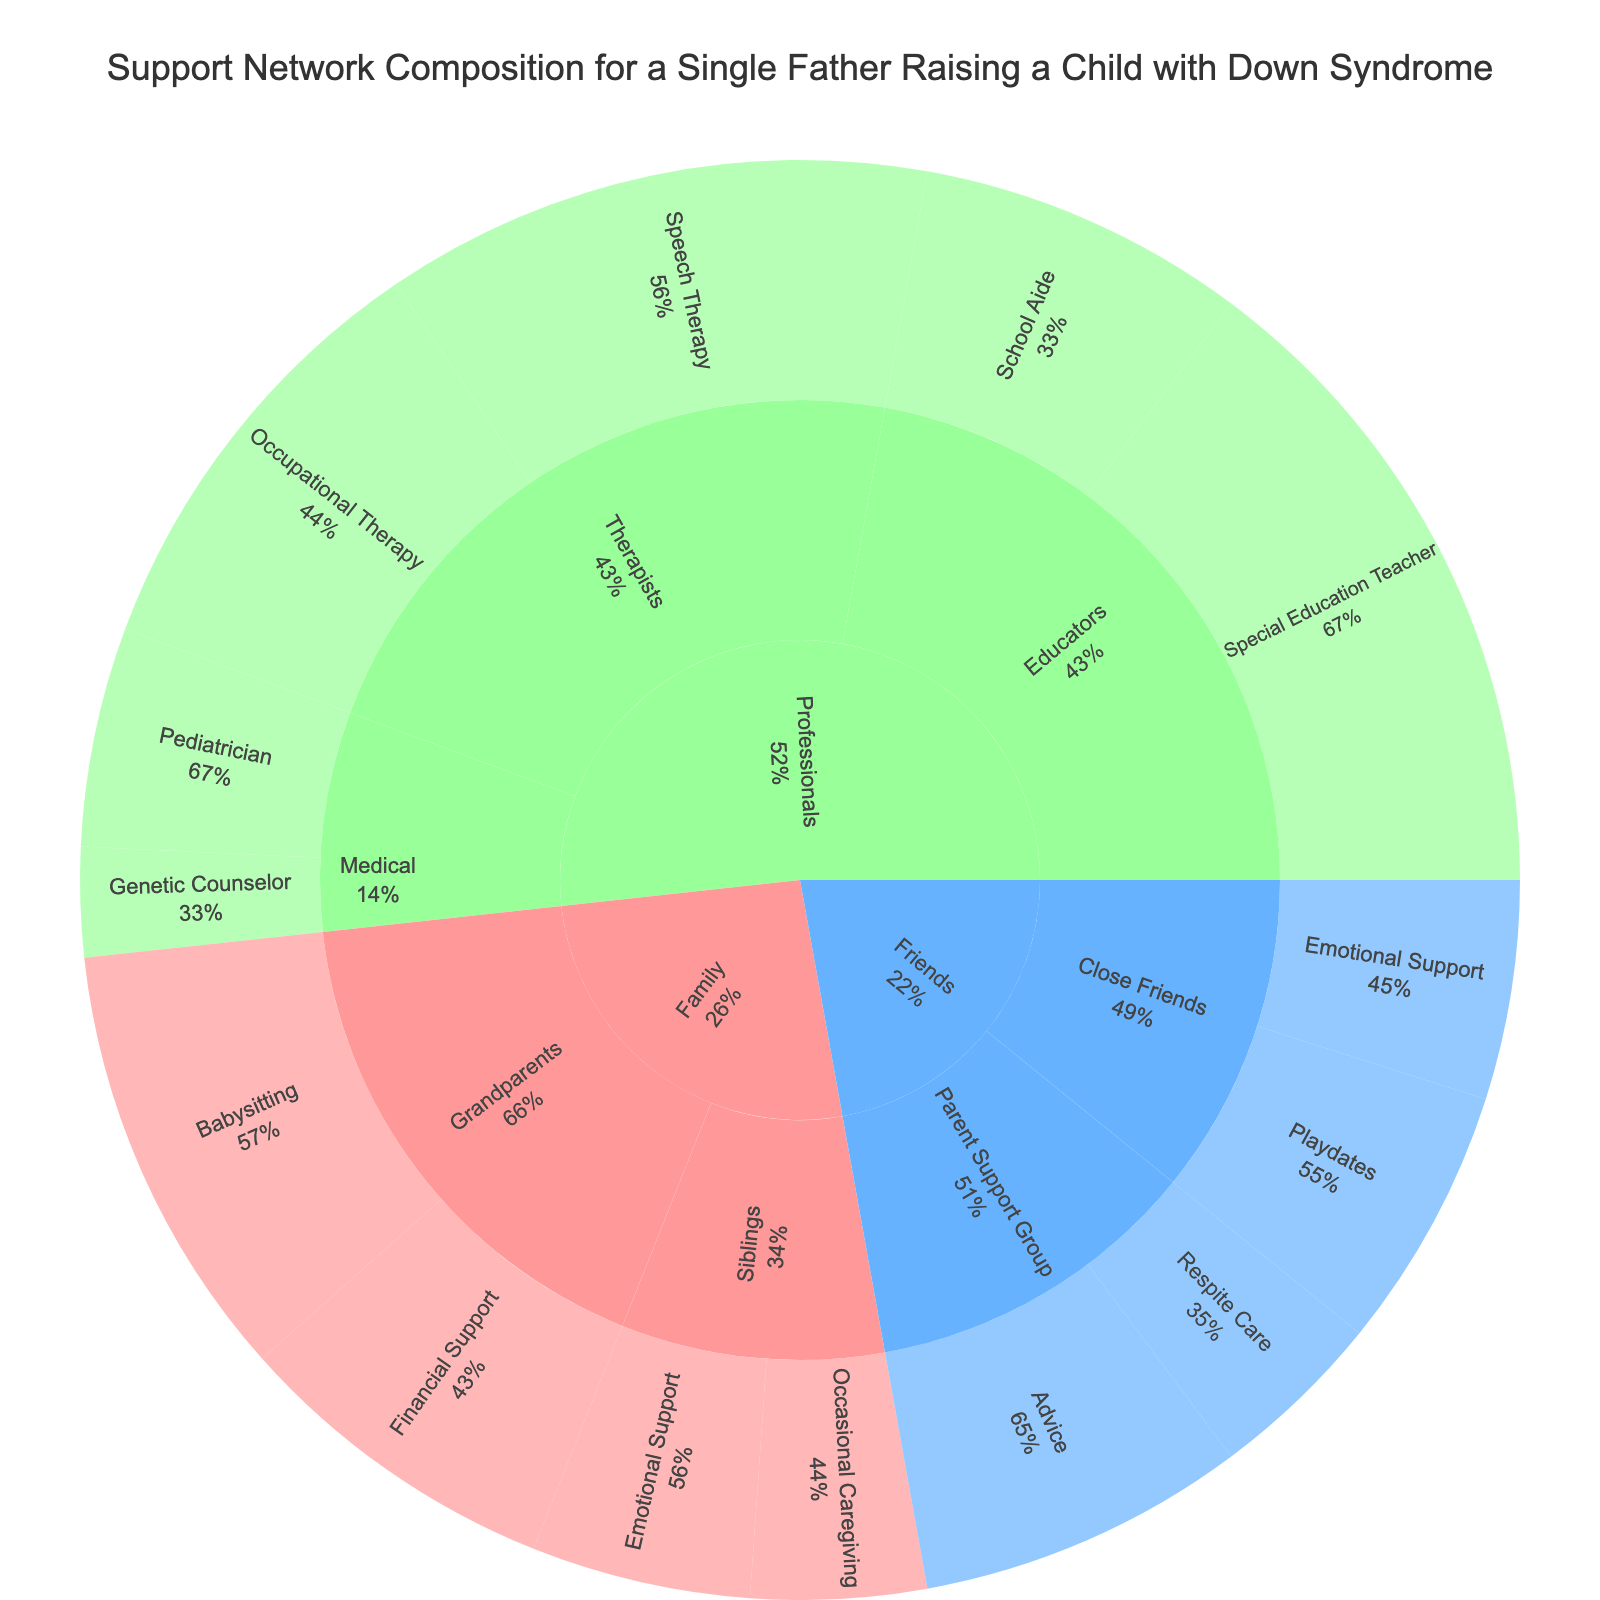What's the title of the sunburst plot? The title is displayed at the top of the figure in a larger font size and different color, designed to be easily noticed.
Answer: Support Network Composition for a Single Father Raising a Child with Down Syndrome What category provides the highest level of support? By looking at the different categories and their respective sizes in the sunburst plot, you can identify which category has the largest segment.
Answer: Professionals How much total support comes from Grandparents? Add the values for all subcategories under Grandparents: Babysitting (20) + Financial Support (15).
Answer: 35 Which type of subsubcategory support within the Friends category has the highest value? Look at the segments under Friends and find the one with the largest proportion.
Answer: Advice Compare the values of Emotional Support provided by Siblings and Close Friends. Which one is higher? Look at the segments under both Siblings and Close Friends, then compare their Emotional Support values.
Answer: Both are equal Which subcategory under Professionals provides more support: Therapists or Educators? Compare the total values for each subcategory by summing their respective sub-subcategories: Therapists (25+20) vs. Educators (30+15).
Answer: Educators What percentage of the total support value is provided by the Special Education Teacher? Find the segment representing the Special Education Teacher and calculate its proportion of the total summed value.
Answer: 12% How many different types of support are provided by Professionals in total? Count the number of sub-subcategories under the Professionals category by looking at the sunburst plot.
Answer: 6 Is the support provided by Parent Support Groups more than that provided by Pediatricians? Compare the summed values for Parent Support Groups (Advice + Respite Care) and Pediatricians.
Answer: Yes What's the smallest value among the subsubcategories under Professionals? Look at each subsubcategory under Professionals and identify the one with the smallest value.
Answer: Genetic Counselor 